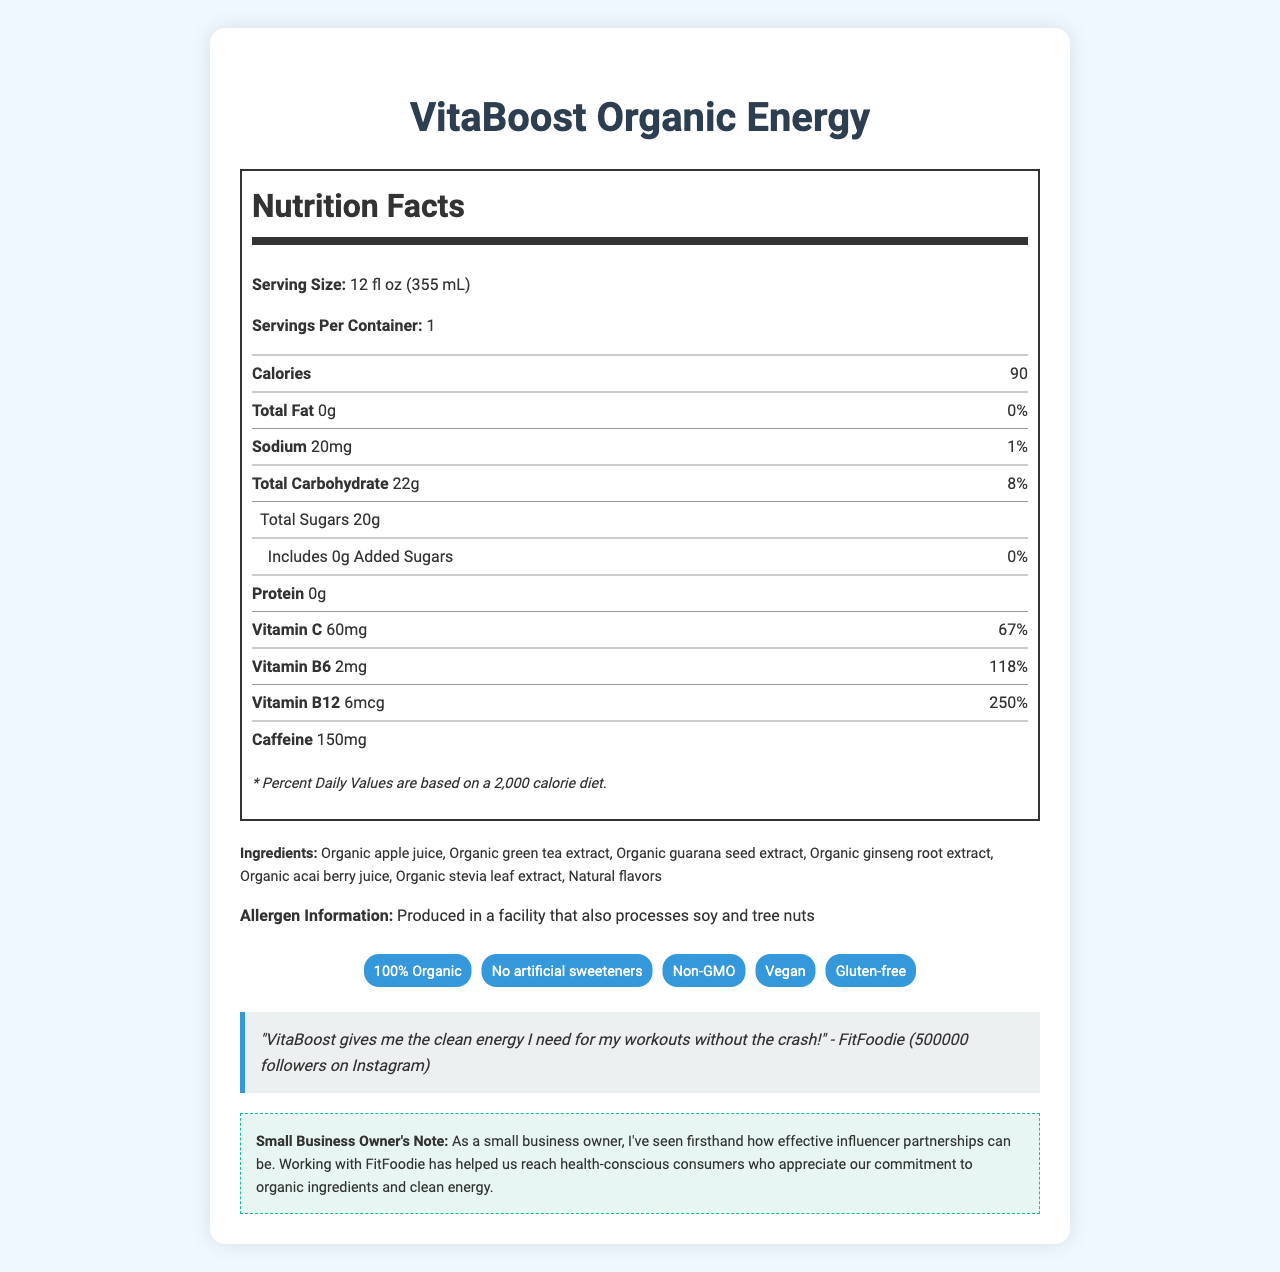How many calories are in one serving of VitaBoost Organic Energy? The document lists 90 calories under the "Calories" section in the Nutrition Facts label.
Answer: 90 What is the amount of Sodium in VitaBoost Organic Energy? The Nutrition Facts label specifies that the sodium content is 20mg.
Answer: 20mg What percentage of the Daily Value of Vitamin C does VitaBoost Organic Energy provide? The vitamin C Daily Value percentage is listed as 67% in the Nutrition Facts label.
Answer: 67% What ingredients are used in VitaBoost Organic Energy? The ingredients are listed in the "Ingredients" section of the document.
Answer: Organic apple juice, Organic green tea extract, Organic guarana seed extract, Organic ginseng root extract, Organic acai berry juice, Organic stevia leaf extract, Natural flavors How much caffeine does VitaBoost Organic Energy contain? The Nutrition Facts label shows 150mg of caffeine.
Answer: 150mg What marketing claims are made about VitaBoost Organic Energy? A. 100% Organic, Vegan, Gluten-free B. No artificial sweeteners, Non-GMO, Dairy-free C. Non-GMO,100% Organic, Has added sugars The document lists "100% Organic," "No artificial sweeteners," "Non-GMO," "Vegan," and "Gluten-free" as marketing claims.
Answer: A Which influencer is associated with VitaBoost Organic Energy? A. FitFoodie B. HealthGuru C. YogaLover123 The document states that FitFoodie is the influencer involved in the partnership.
Answer: A Is it true that VitaBoost Organic Energy contains added sugars? The document shows "Includes 0g Added Sugars" with a daily value of "0%" in the Nutrition Facts label.
Answer: No Can we determine the revenue generated from VitaBoost Organic Energy sales from the document? The document provides nutritional and marketing information but does not mention any sales or revenue figures.
Answer: Cannot be determined Summarize the main idea of this document. This summary captures the key points, detailing what the product is, its nutritional content, claims, and marketing strategy using an influencer.
Answer: VitaBoost Organic Energy is an organic energy drink that emphasizes natural ingredients and is marketed through influencer partnerships. The document provides detailed nutrition information, ingredient lists, allergen information, and marketing claims. It highlights a testimonial from an influencer, FitFoodie, and includes a note from the small business owner about the success of influencer marketing. 